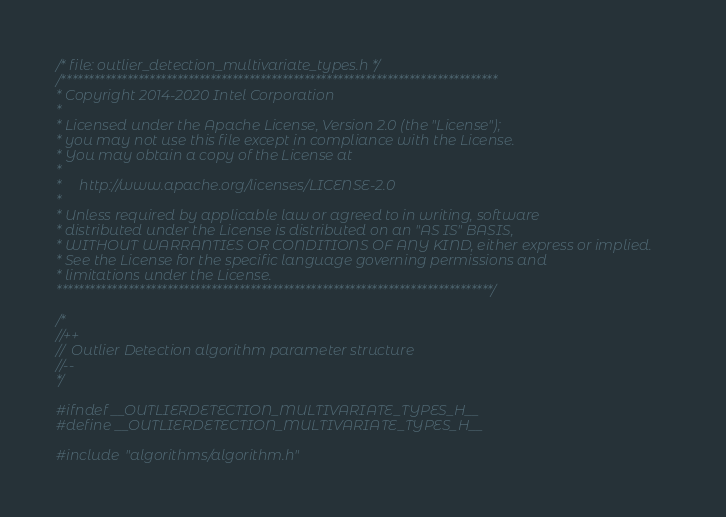Convert code to text. <code><loc_0><loc_0><loc_500><loc_500><_C_>/* file: outlier_detection_multivariate_types.h */
/*******************************************************************************
* Copyright 2014-2020 Intel Corporation
*
* Licensed under the Apache License, Version 2.0 (the "License");
* you may not use this file except in compliance with the License.
* You may obtain a copy of the License at
*
*     http://www.apache.org/licenses/LICENSE-2.0
*
* Unless required by applicable law or agreed to in writing, software
* distributed under the License is distributed on an "AS IS" BASIS,
* WITHOUT WARRANTIES OR CONDITIONS OF ANY KIND, either express or implied.
* See the License for the specific language governing permissions and
* limitations under the License.
*******************************************************************************/

/*
//++
//  Outlier Detection algorithm parameter structure
//--
*/

#ifndef __OUTLIERDETECTION_MULTIVARIATE_TYPES_H__
#define __OUTLIERDETECTION_MULTIVARIATE_TYPES_H__

#include "algorithms/algorithm.h"</code> 